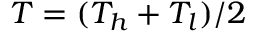<formula> <loc_0><loc_0><loc_500><loc_500>T = ( T _ { h } + T _ { l } ) / 2</formula> 